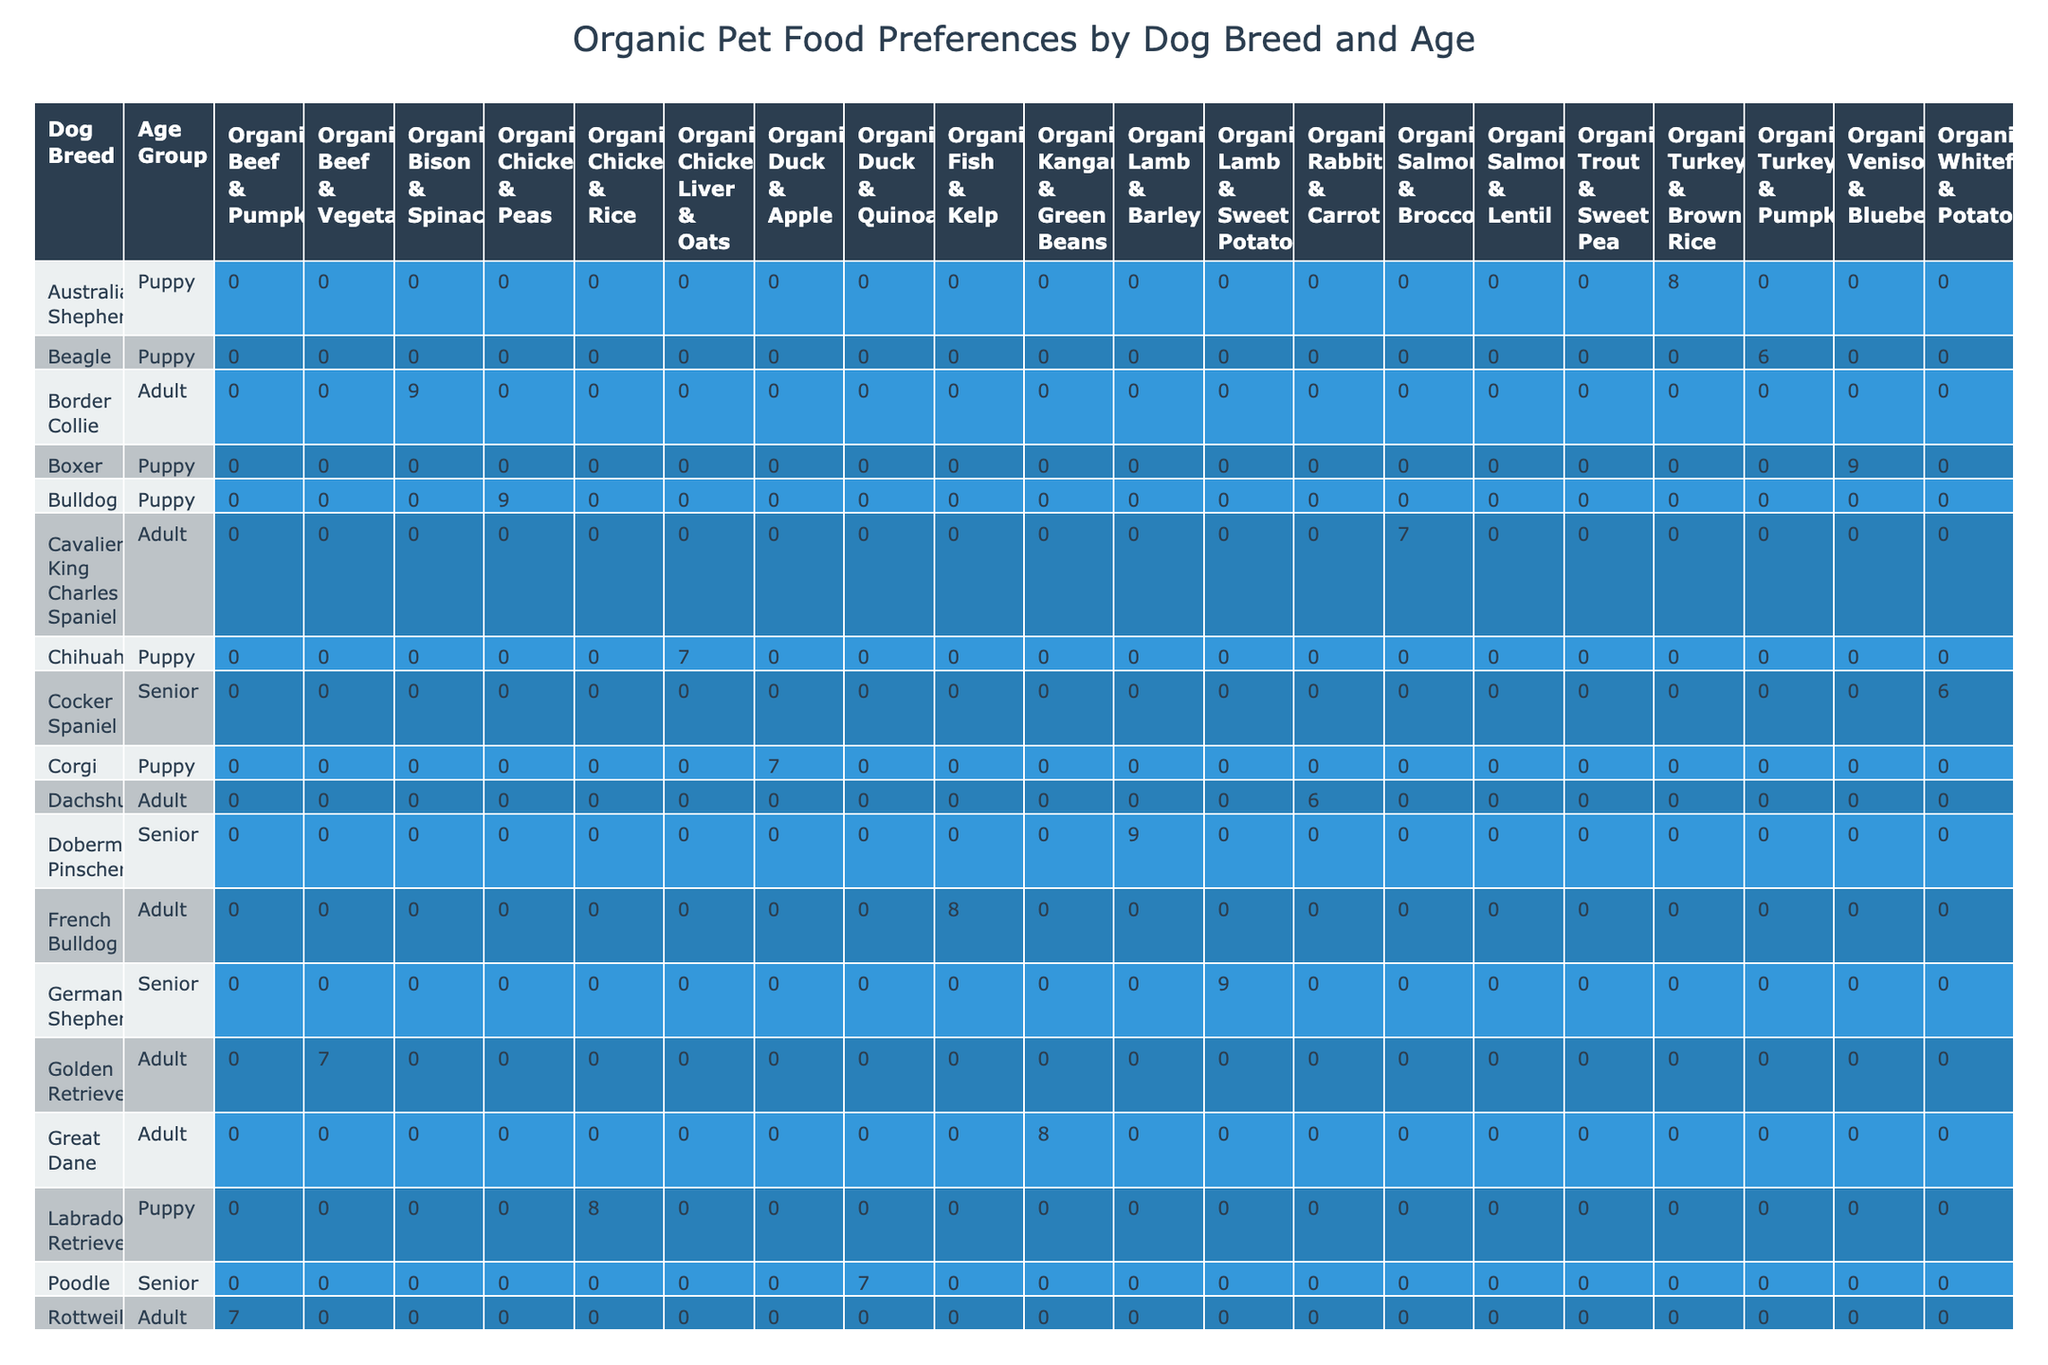What dog breed has the highest preference score for organic food? The highest preference score in the table is 9. The breeds that received this score are Boxer, German Shepherd, and Doberman Pinscher. The question requires reviewing the scores for each dog breed, and upon comparison, it can be seen that these three breeds achieved the highest score.
Answer: Boxer, German Shepherd, Doberman Pinscher Which age group shows a higher preference for organic food, puppies or adults? By examining the preference scores for puppies and adults across all dog breeds, we summarize the scores: Puppies yield scores of 8, 7, 9, 6, 8, 7, 9, and Adults score 7, 8, 9, 6, 8, 7. Thus, the average for puppies is 7.25 (calculated as 8+7+9+6+8+7+9 = 54, divided by 8) while adults average 7.5 (7+8+9+6+8+7=45, divided by 6). Therefore, adults have a higher average score.
Answer: Adults What is the total sales volume for all organic chicken varieties? The organic chicken varieties include Organic Chicken & Rice and Organic Chicken Liver & Oats. Their sales volumes are 1200 (for Organic Chicken & Rice) and 300 (for Organic Chicken Liver & Oats). To find the total sales volume, sum these values: 1200 + 300 = 1500.
Answer: 1500 Is there any organic food type preferred by both puppies and adults? To determine if any organic food type is preferred by both age groups, we check the table for any food types listed under Puppies and Adults. Organic Turkey & Pumpkin is listed for Puppies but not for Adults, and Organic Beef & Vegetable is listed for Adults but not for Puppies. Upon reviewing all entries, it appears there are no overlaps in organic food types between Puppies and Adults.
Answer: No What is the average preference score for the seniors' organic food options? There are three senior dogs listed: German Shepherd (9), Poodle (7), and Shih Tzu (6). To find the average preference score for seniors, we sum these scores: 9 + 7 + 6 = 22. There are 3 data points, so the average is 22 / 3 = 7.33.
Answer: 7.33 